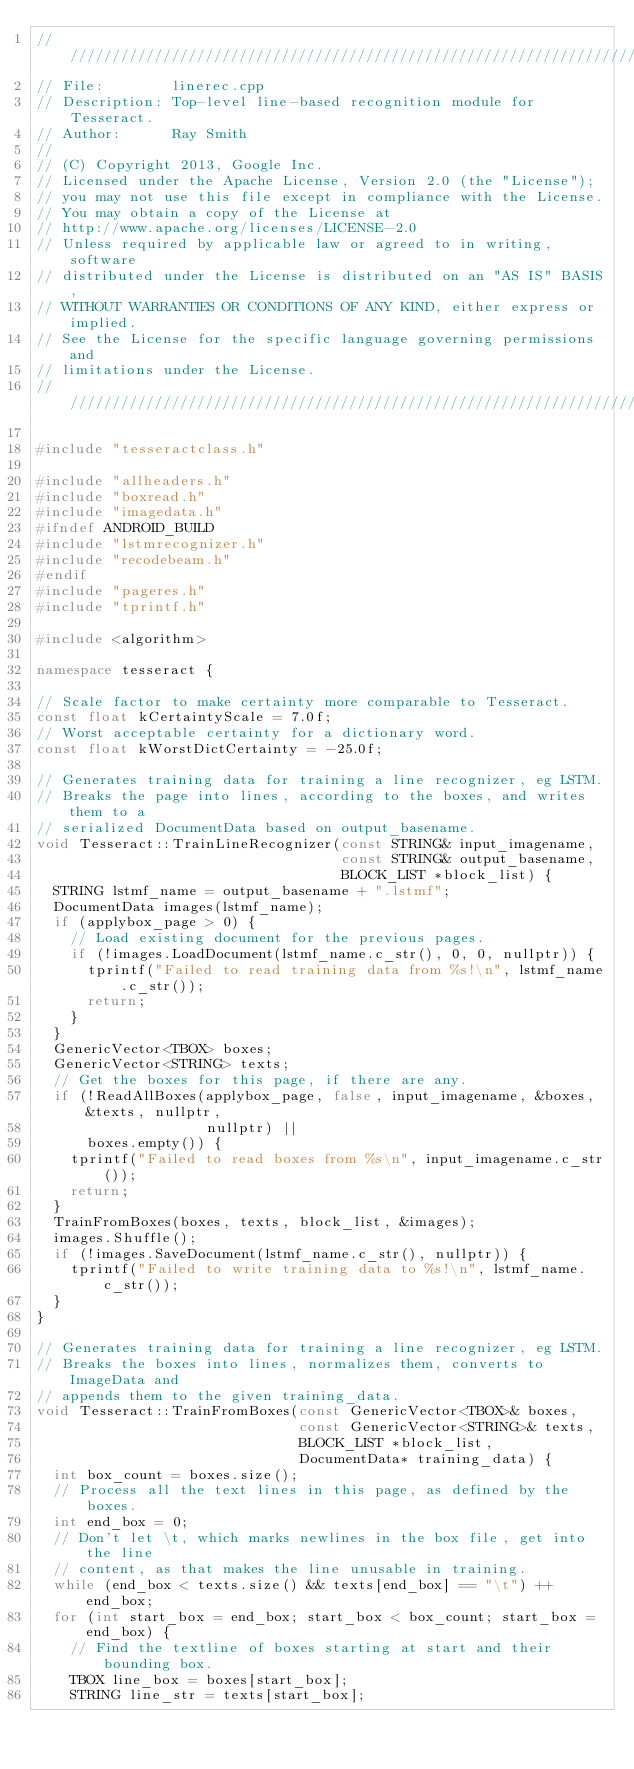Convert code to text. <code><loc_0><loc_0><loc_500><loc_500><_C++_>///////////////////////////////////////////////////////////////////////
// File:        linerec.cpp
// Description: Top-level line-based recognition module for Tesseract.
// Author:      Ray Smith
//
// (C) Copyright 2013, Google Inc.
// Licensed under the Apache License, Version 2.0 (the "License");
// you may not use this file except in compliance with the License.
// You may obtain a copy of the License at
// http://www.apache.org/licenses/LICENSE-2.0
// Unless required by applicable law or agreed to in writing, software
// distributed under the License is distributed on an "AS IS" BASIS,
// WITHOUT WARRANTIES OR CONDITIONS OF ANY KIND, either express or implied.
// See the License for the specific language governing permissions and
// limitations under the License.
///////////////////////////////////////////////////////////////////////

#include "tesseractclass.h"

#include "allheaders.h"
#include "boxread.h"
#include "imagedata.h"
#ifndef ANDROID_BUILD
#include "lstmrecognizer.h"
#include "recodebeam.h"
#endif
#include "pageres.h"
#include "tprintf.h"

#include <algorithm>

namespace tesseract {

// Scale factor to make certainty more comparable to Tesseract.
const float kCertaintyScale = 7.0f;
// Worst acceptable certainty for a dictionary word.
const float kWorstDictCertainty = -25.0f;

// Generates training data for training a line recognizer, eg LSTM.
// Breaks the page into lines, according to the boxes, and writes them to a
// serialized DocumentData based on output_basename.
void Tesseract::TrainLineRecognizer(const STRING& input_imagename,
                                    const STRING& output_basename,
                                    BLOCK_LIST *block_list) {
  STRING lstmf_name = output_basename + ".lstmf";
  DocumentData images(lstmf_name);
  if (applybox_page > 0) {
    // Load existing document for the previous pages.
    if (!images.LoadDocument(lstmf_name.c_str(), 0, 0, nullptr)) {
      tprintf("Failed to read training data from %s!\n", lstmf_name.c_str());
      return;
    }
  }
  GenericVector<TBOX> boxes;
  GenericVector<STRING> texts;
  // Get the boxes for this page, if there are any.
  if (!ReadAllBoxes(applybox_page, false, input_imagename, &boxes, &texts, nullptr,
                    nullptr) ||
      boxes.empty()) {
    tprintf("Failed to read boxes from %s\n", input_imagename.c_str());
    return;
  }
  TrainFromBoxes(boxes, texts, block_list, &images);
  images.Shuffle();
  if (!images.SaveDocument(lstmf_name.c_str(), nullptr)) {
    tprintf("Failed to write training data to %s!\n", lstmf_name.c_str());
  }
}

// Generates training data for training a line recognizer, eg LSTM.
// Breaks the boxes into lines, normalizes them, converts to ImageData and
// appends them to the given training_data.
void Tesseract::TrainFromBoxes(const GenericVector<TBOX>& boxes,
                               const GenericVector<STRING>& texts,
                               BLOCK_LIST *block_list,
                               DocumentData* training_data) {
  int box_count = boxes.size();
  // Process all the text lines in this page, as defined by the boxes.
  int end_box = 0;
  // Don't let \t, which marks newlines in the box file, get into the line
  // content, as that makes the line unusable in training.
  while (end_box < texts.size() && texts[end_box] == "\t") ++end_box;
  for (int start_box = end_box; start_box < box_count; start_box = end_box) {
    // Find the textline of boxes starting at start and their bounding box.
    TBOX line_box = boxes[start_box];
    STRING line_str = texts[start_box];</code> 